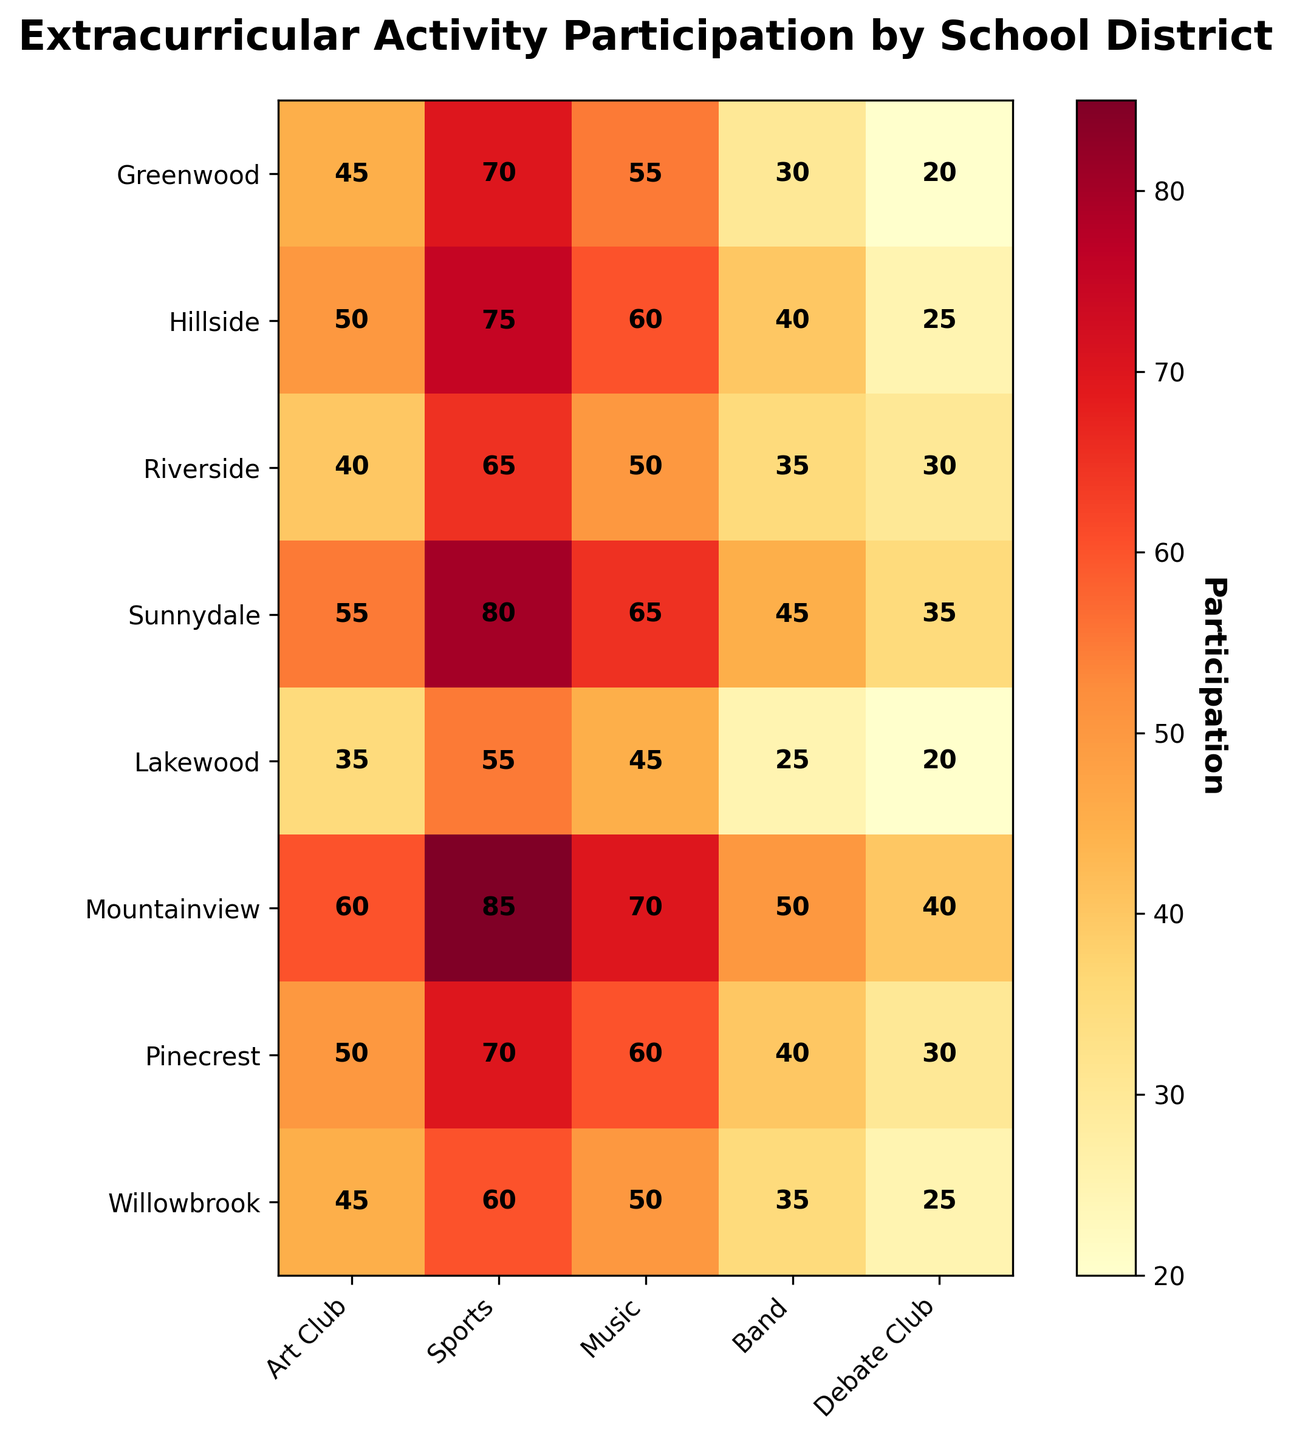What is the participation percentage for Music in Sunnydale? To find this information, look at the intersection of the "Music" column and the "Sunnydale" row on the heatmap.
Answer: 65 What is the highest participation percentage among all extracurricular activities? Identify the cell with the highest value in the entire heatmap, which represents the highest participation percentage.
Answer: 85 Which school district has the lowest participation in Band? Find the smallest number in the "Band" column and see which row (school district) it corresponds to.
Answer: Lakewood What is the average participation percentage in Debate Club across all school districts? Sum the participation percentages in the "Debate Club" column (20 + 25 + 30 + 35 + 20 + 40 + 30 + 25) and divide by the number of districts (8).
Answer: 28.125 How does participation in Art Club compare between Greenwood and Riverside? Locate the participation numbers for "Art Club" in both "Greenwood" and "Riverside". Compare 45 (Greenwood) to 40 (Riverside).
Answer: Greenwood has 5% more Which extracurricular activity has the most consistent participation across school districts? By observing the heatmap, determine which column (activity) has relatively similar values across different rows (districts).
Answer: Music In which extracurricular activity does Hillside have the highest participation? Look at the row for "Hillside" and find the column with the highest value.
Answer: Sports If you sum the participation percentages for all activities in Mountainview, what is the total? Add the participation numbers within the "Mountainview" row: 60 (Art Club) + 85 (Sports) + 70 (Music) + 50 (Band) + 40 (Debate Club).
Answer: 305 Which two school districts have equal participation in any activity? Scan through the heatmap to identify any matching participation numbers in the same column for two different rows. Example: "Art Club" with 45 for both Greenwood and Willowbrook.
Answer: Greenwood and Willowbrook in Art Club What is the difference in Sports participation between Sunnydale and Lakewood? Subtract the Sports participation percentage of Lakewood from that of Sunnydale: 80 (Sunnydale) - 55 (Lakewood).
Answer: 25 